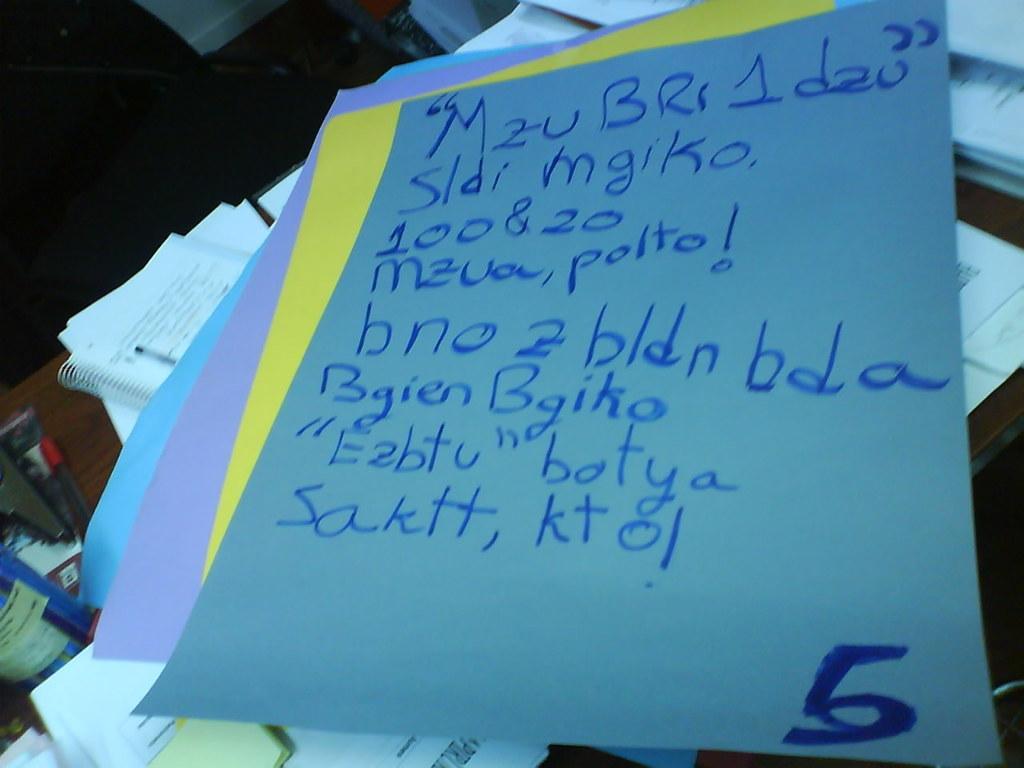In one or two sentences, can you explain what this image depicts? In this picture, we see the chart papers in blue, violet and yellow color. Behind that, we see the books, papers, pen and some objects are placed on the brown table. In the left top, it is black in color. 